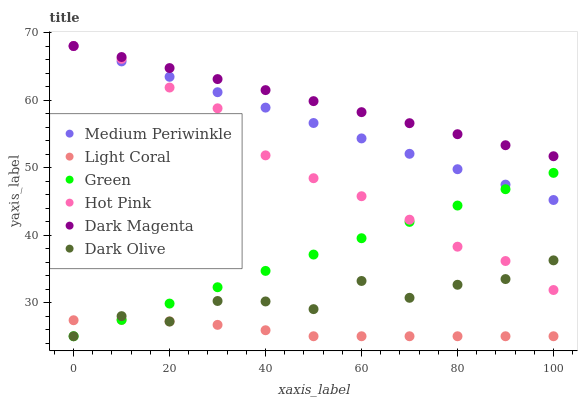Does Light Coral have the minimum area under the curve?
Answer yes or no. Yes. Does Dark Magenta have the maximum area under the curve?
Answer yes or no. Yes. Does Dark Olive have the minimum area under the curve?
Answer yes or no. No. Does Dark Olive have the maximum area under the curve?
Answer yes or no. No. Is Green the smoothest?
Answer yes or no. Yes. Is Dark Olive the roughest?
Answer yes or no. Yes. Is Dark Magenta the smoothest?
Answer yes or no. No. Is Dark Magenta the roughest?
Answer yes or no. No. Does Dark Olive have the lowest value?
Answer yes or no. Yes. Does Dark Magenta have the lowest value?
Answer yes or no. No. Does Medium Periwinkle have the highest value?
Answer yes or no. Yes. Does Dark Olive have the highest value?
Answer yes or no. No. Is Light Coral less than Medium Periwinkle?
Answer yes or no. Yes. Is Dark Magenta greater than Dark Olive?
Answer yes or no. Yes. Does Medium Periwinkle intersect Dark Magenta?
Answer yes or no. Yes. Is Medium Periwinkle less than Dark Magenta?
Answer yes or no. No. Is Medium Periwinkle greater than Dark Magenta?
Answer yes or no. No. Does Light Coral intersect Medium Periwinkle?
Answer yes or no. No. 